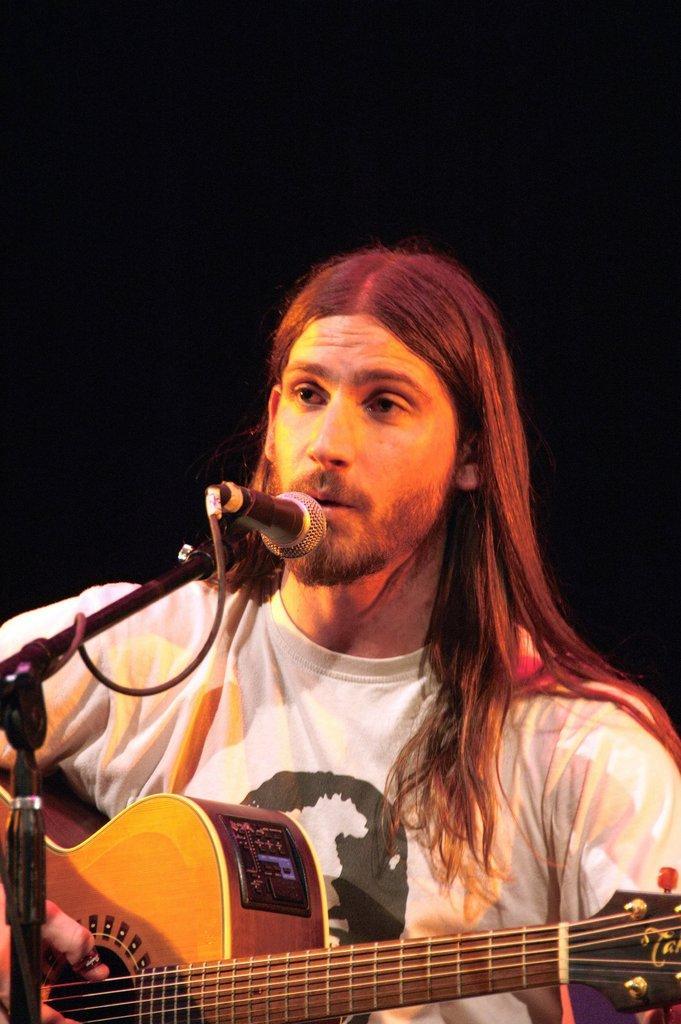Can you describe this image briefly? He is a man holding a guitar in his hands and he is singing on a microphone. 